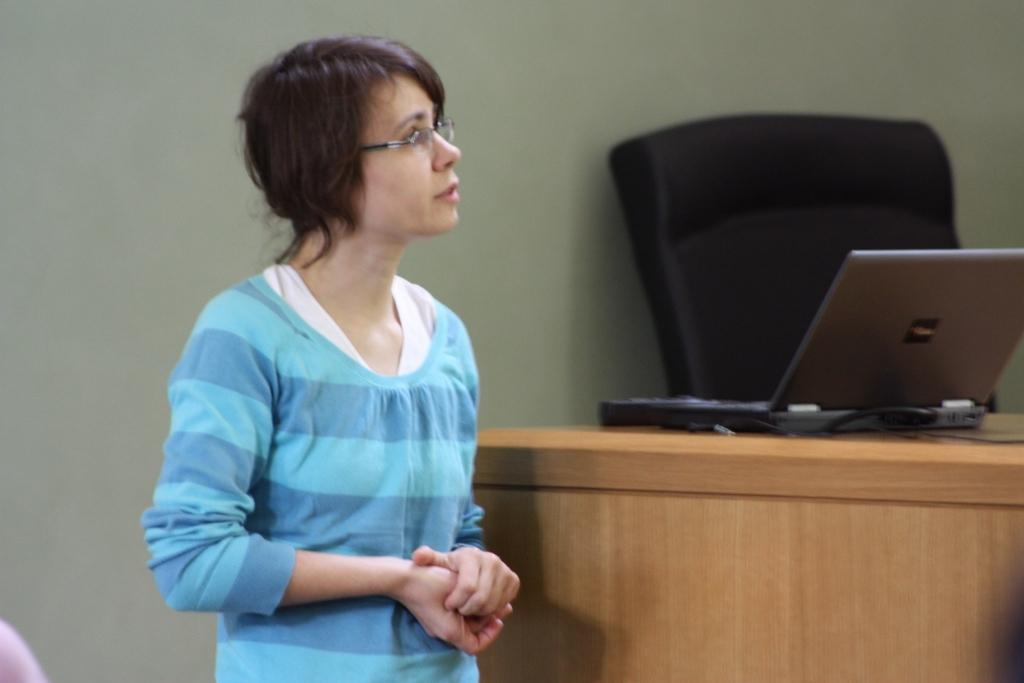Who is the main subject in the image? There is a woman in the image. What is the woman wearing? The woman is wearing a blue dress and glasses (specs). What can be seen in the background of the image? There is a laptop and a chair in the background of the image. Can you tell me how many deer are visible in the image? There are no deer present in the image. What type of nest can be seen in the woman's hair in the image? There is no nest visible in the image, and the woman's hair is not mentioned in the provided facts. 